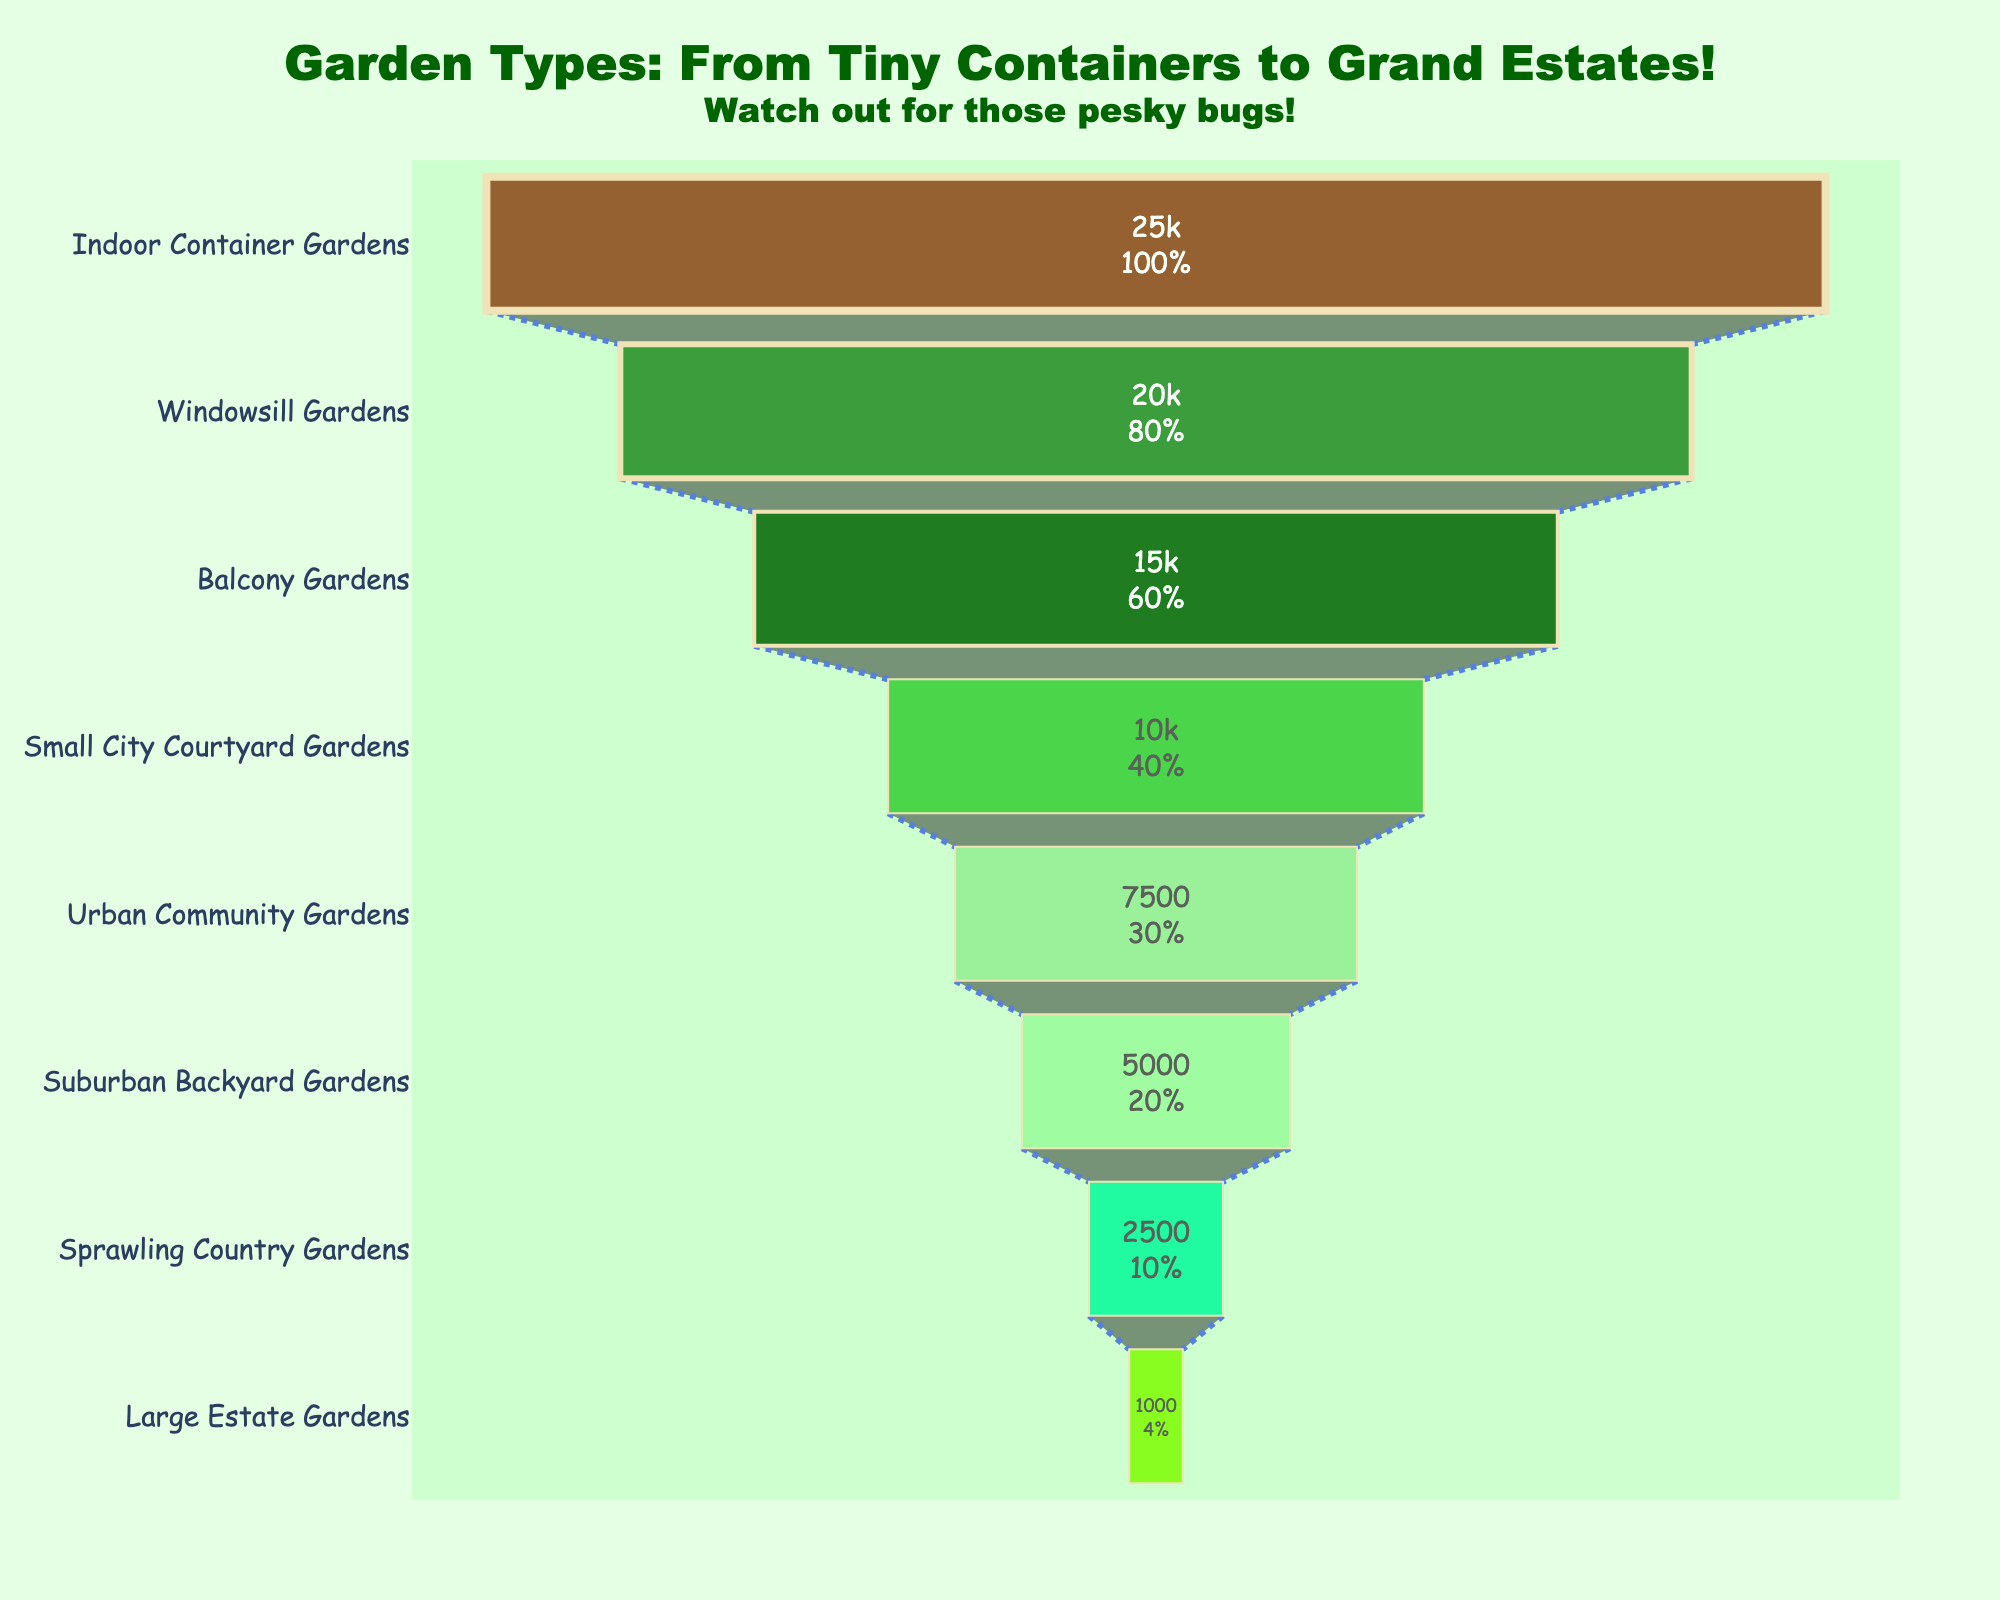What garden type has the highest number of gardens? The garden type with the highest number of gardens is the one at the widest part of the funnel chart, which represents the largest quantity. The widest section at the top of the chart is "Indoor Container Gardens."
Answer: Indoor Container Gardens What percentage of gardens are Urban Community Gardens compared to the initial total? The funnel chart provides detailed information on the percentage. The chart shows both the absolute number and the percentage of each type compared to the total number of gardens. Urban Community Gardens make up 7,500 of the total. Given the cumulative nature of the chart, this can be read directly from the chart at the Urban Community Gardens segment.
Answer: 10% How many more Suburban Backyard Gardens are there compared to Sprawling Country Gardens? Suburban Backyard Gardens have 5,000 gardens, while Sprawling Country Gardens have 2,500 gardens. The difference between them is 5,000 - 2,500 which equals 2,500.
Answer: 2,500 What's the total number of Windowsill Gardens and Balcony Gardens combined? The chart shows 20,000 Windowsill Gardens and 15,000 Balcony Gardens. Adding them together, 20,000 + 15,000 equals 35,000.
Answer: 35,000 Which is greater: the number of Small City Courtyard Gardens or the number of Urban Community Gardens? Small City Courtyard Gardens have 10,000 gardens while Urban Community Gardens have 7,500 gardens. Comparing the two, 10,000 is greater than 7,500.
Answer: Small City Courtyard Gardens What is the smallest type of garden represented in the chart? The smallest type of garden is the one at the narrowest point of the funnel, which represents the smallest quantity. The narrowest section at the bottom of the chart is "Large Estate Gardens."
Answer: Large Estate Gardens If you aggregate the number of gardens from Small City Courtyard Gardens to Large Estate Gardens, what will be the total? The gardens from Small City Courtyard to Large Estate are 10,000 (Small City Courtyard) + 7,500 (Urban Community) + 5,000 (Suburban Backyard) + 2,500 (Sprawling Country) + 1,000 (Large Estate). The sum is 10,000 + 7,500 + 5,000 + 2,500 + 1,000 = 26,000.
Answer: 26,000 What is the median number of gardens considering all the types? To find the median, we should arrange the garden numbers: 1,000, 2,500, 5,000, 7,500, 10,000, 15,000, 20,000, 25,000. Since there is an even number of data points (8), the median is the average of the 4th and 5th values (7,500 and 10,000). Median = (7,500 + 10,000) / 2 = 8,750.
Answer: 8,750 